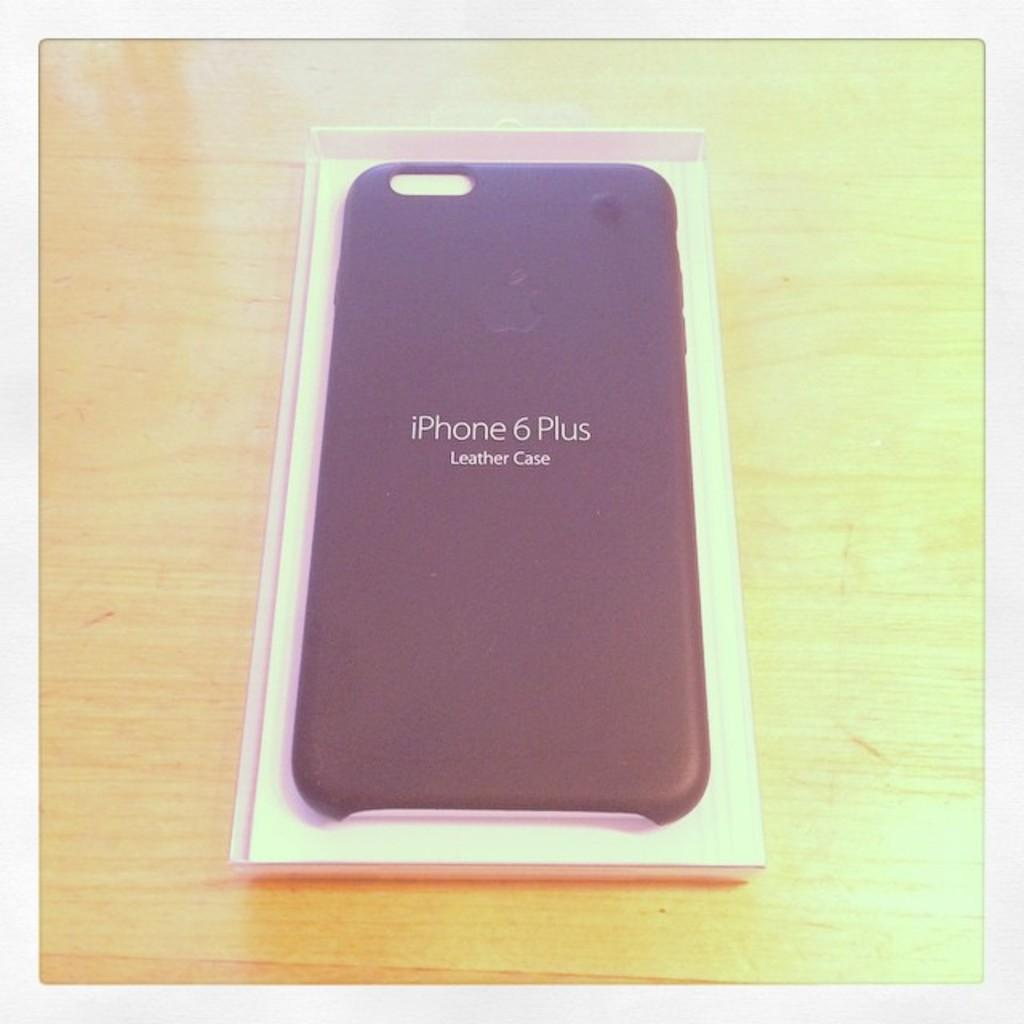<image>
Write a terse but informative summary of the picture. The rear of an iphone 6 plus seen within a purple leather case. 